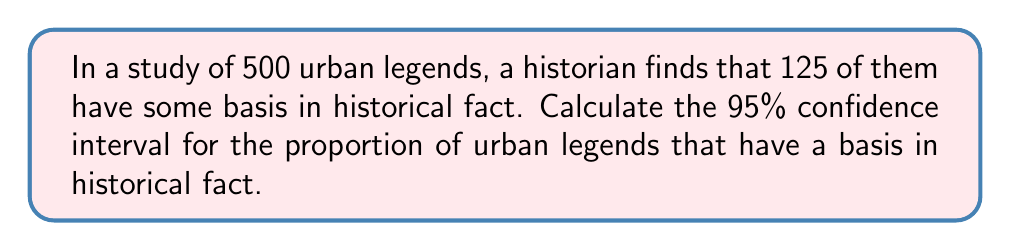Can you solve this math problem? To calculate the confidence interval, we'll use the following steps:

1. Calculate the sample proportion:
   $\hat{p} = \frac{125}{500} = 0.25$

2. Calculate the standard error:
   $SE = \sqrt{\frac{\hat{p}(1-\hat{p})}{n}} = \sqrt{\frac{0.25(1-0.25)}{500}} = 0.0194$

3. Find the critical value for a 95% confidence interval:
   For a 95% CI, we use $z_{0.025} = 1.96$

4. Calculate the margin of error:
   $E = z_{0.025} \times SE = 1.96 \times 0.0194 = 0.0380$

5. Determine the confidence interval:
   Lower bound: $\hat{p} - E = 0.25 - 0.0380 = 0.2120$
   Upper bound: $\hat{p} + E = 0.25 + 0.0380 = 0.2880$

Therefore, the 95% confidence interval is (0.2120, 0.2880) or (21.20%, 28.80%).
Answer: (0.2120, 0.2880) 